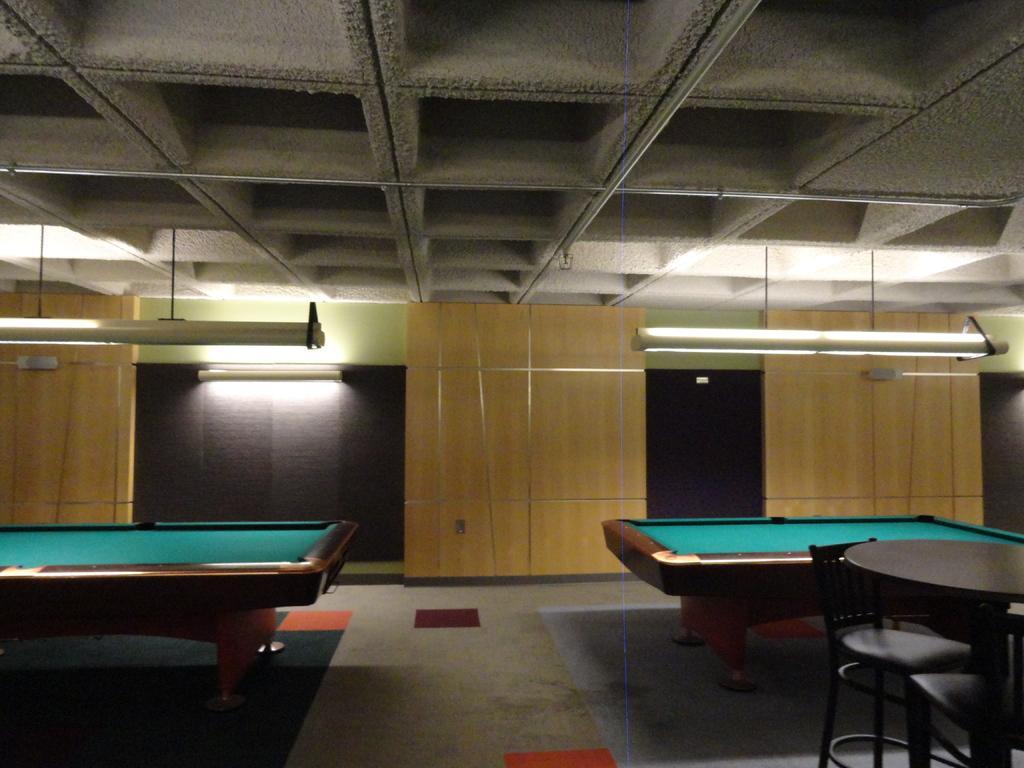Describe this image in one or two sentences. In this image we can see two billiard tables in a room and to the side we can see a table with two chairs. We can see some lights and wooden wall in the background. 